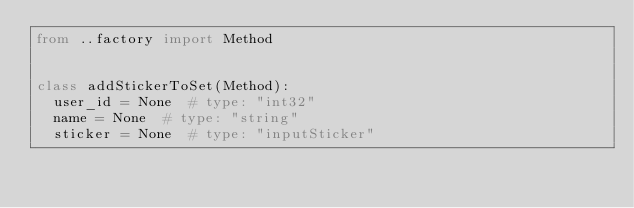<code> <loc_0><loc_0><loc_500><loc_500><_Python_>from ..factory import Method


class addStickerToSet(Method):
	user_id = None  # type: "int32"
	name = None  # type: "string"
	sticker = None  # type: "inputSticker"
</code> 